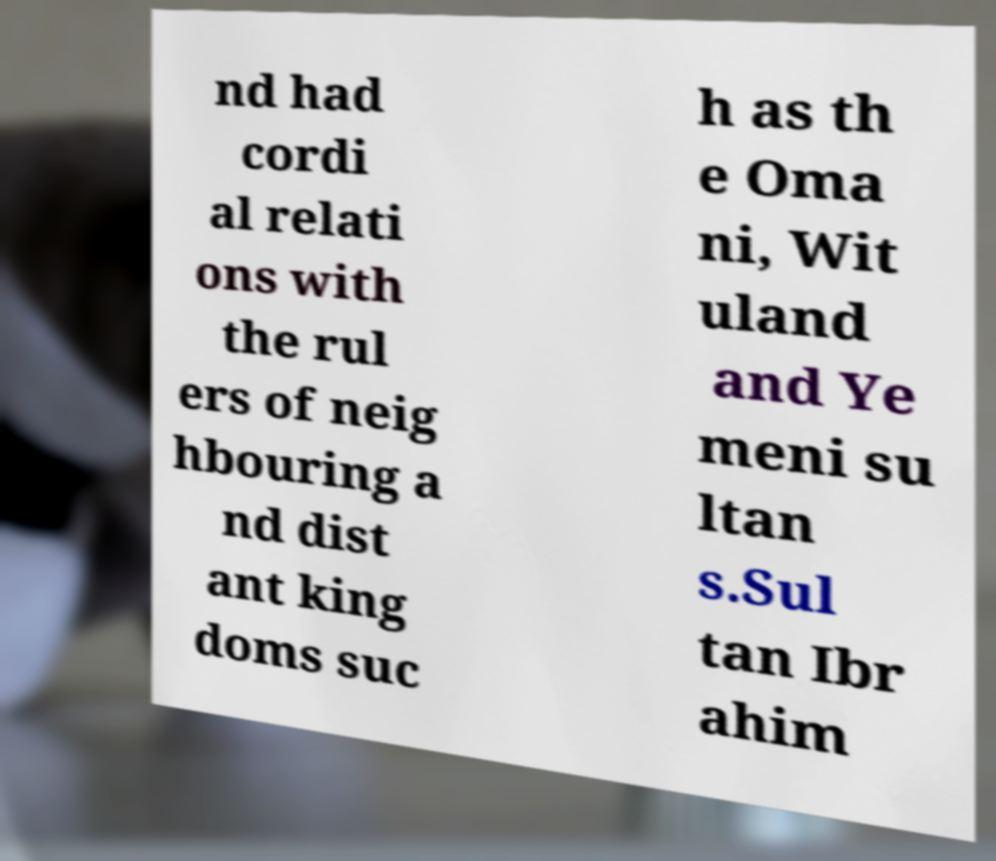What messages or text are displayed in this image? I need them in a readable, typed format. nd had cordi al relati ons with the rul ers of neig hbouring a nd dist ant king doms suc h as th e Oma ni, Wit uland and Ye meni su ltan s.Sul tan Ibr ahim 